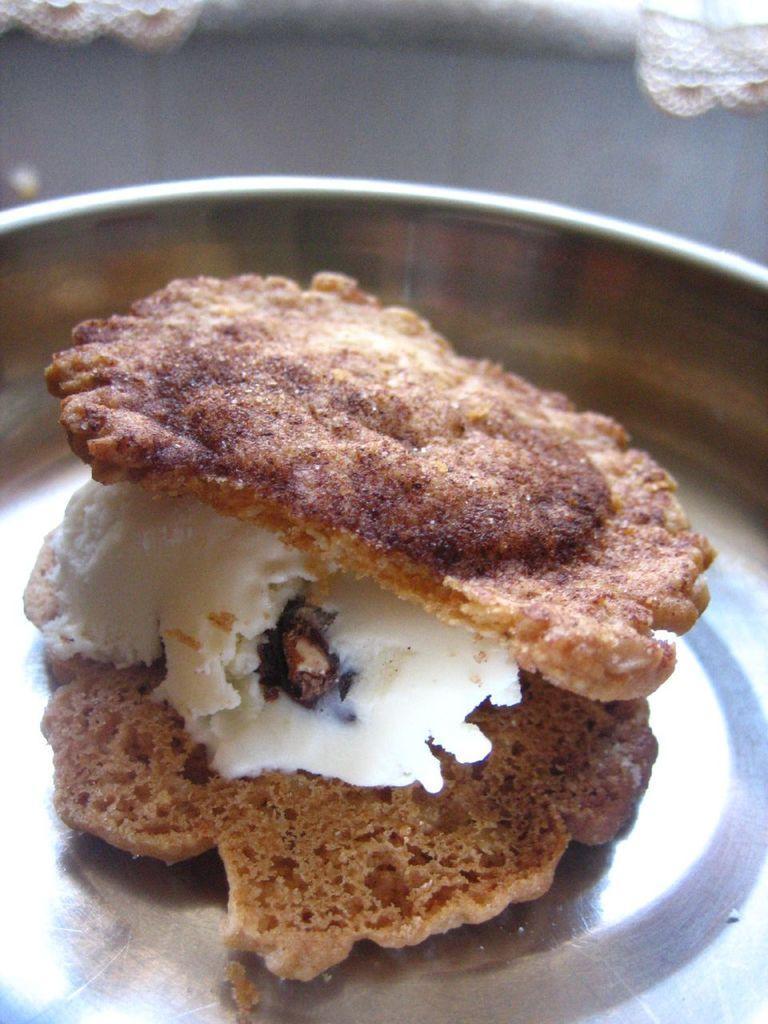Can you describe this image briefly? In this image we can see the food on a plate. 